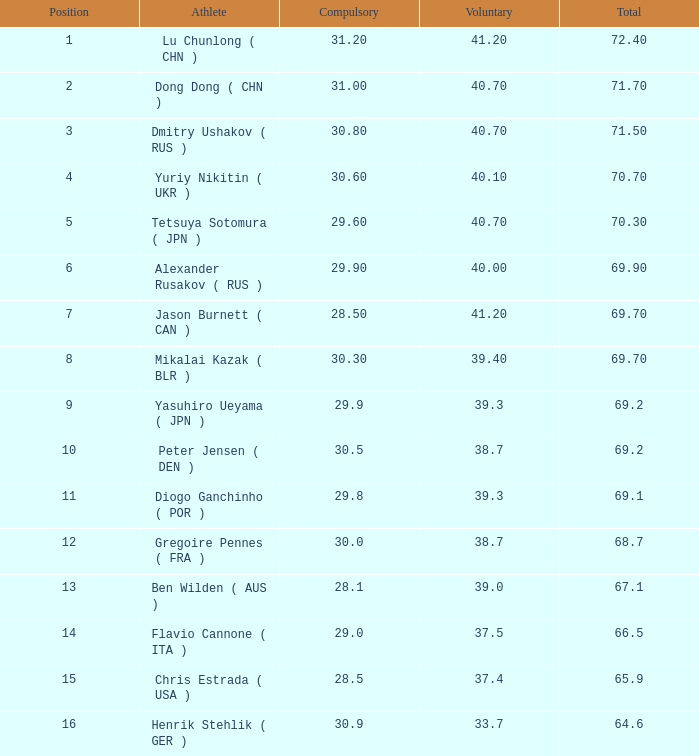9, and optional below 3 None. 